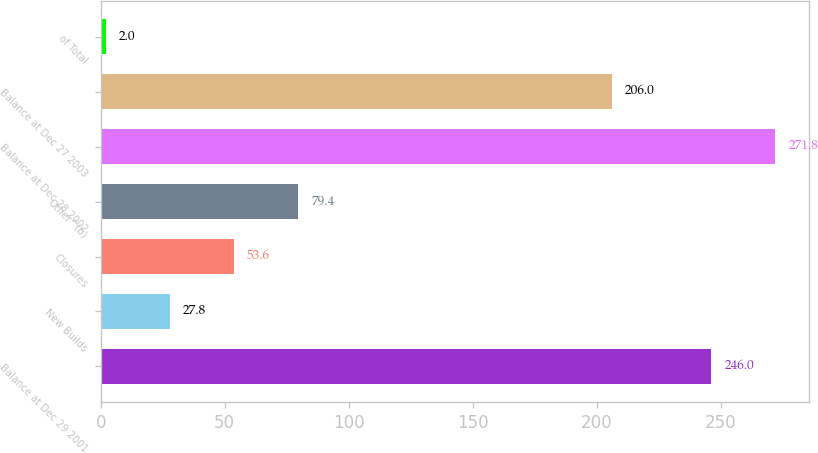<chart> <loc_0><loc_0><loc_500><loc_500><bar_chart><fcel>Balance at Dec 29 2001<fcel>New Builds<fcel>Closures<fcel>Other^(b)<fcel>Balance at Dec 28 2002<fcel>Balance at Dec 27 2003<fcel>of Total<nl><fcel>246<fcel>27.8<fcel>53.6<fcel>79.4<fcel>271.8<fcel>206<fcel>2<nl></chart> 